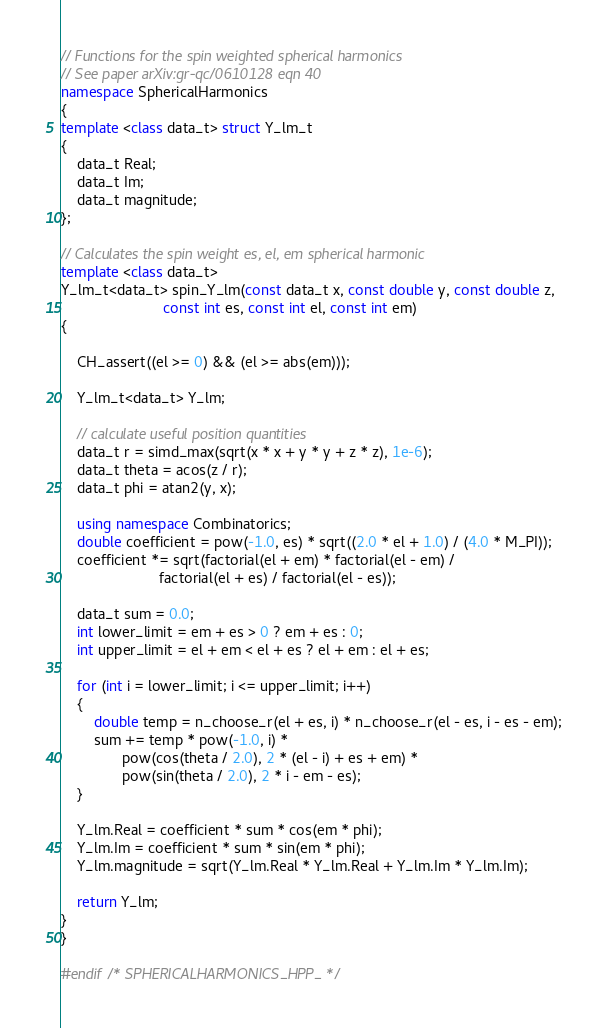Convert code to text. <code><loc_0><loc_0><loc_500><loc_500><_C++_>
// Functions for the spin weighted spherical harmonics
// See paper arXiv:gr-qc/0610128 eqn 40
namespace SphericalHarmonics
{
template <class data_t> struct Y_lm_t
{
    data_t Real;
    data_t Im;
    data_t magnitude;
};

// Calculates the spin weight es, el, em spherical harmonic
template <class data_t>
Y_lm_t<data_t> spin_Y_lm(const data_t x, const double y, const double z,
                         const int es, const int el, const int em)
{

    CH_assert((el >= 0) && (el >= abs(em)));

    Y_lm_t<data_t> Y_lm;

    // calculate useful position quantities
    data_t r = simd_max(sqrt(x * x + y * y + z * z), 1e-6);
    data_t theta = acos(z / r);
    data_t phi = atan2(y, x);

    using namespace Combinatorics;
    double coefficient = pow(-1.0, es) * sqrt((2.0 * el + 1.0) / (4.0 * M_PI));
    coefficient *= sqrt(factorial(el + em) * factorial(el - em) /
                        factorial(el + es) / factorial(el - es));

    data_t sum = 0.0;
    int lower_limit = em + es > 0 ? em + es : 0;
    int upper_limit = el + em < el + es ? el + em : el + es;

    for (int i = lower_limit; i <= upper_limit; i++)
    {
        double temp = n_choose_r(el + es, i) * n_choose_r(el - es, i - es - em);
        sum += temp * pow(-1.0, i) *
               pow(cos(theta / 2.0), 2 * (el - i) + es + em) *
               pow(sin(theta / 2.0), 2 * i - em - es);
    }

    Y_lm.Real = coefficient * sum * cos(em * phi);
    Y_lm.Im = coefficient * sum * sin(em * phi);
    Y_lm.magnitude = sqrt(Y_lm.Real * Y_lm.Real + Y_lm.Im * Y_lm.Im);

    return Y_lm;
}
}

#endif /* SPHERICALHARMONICS_HPP_ */
</code> 